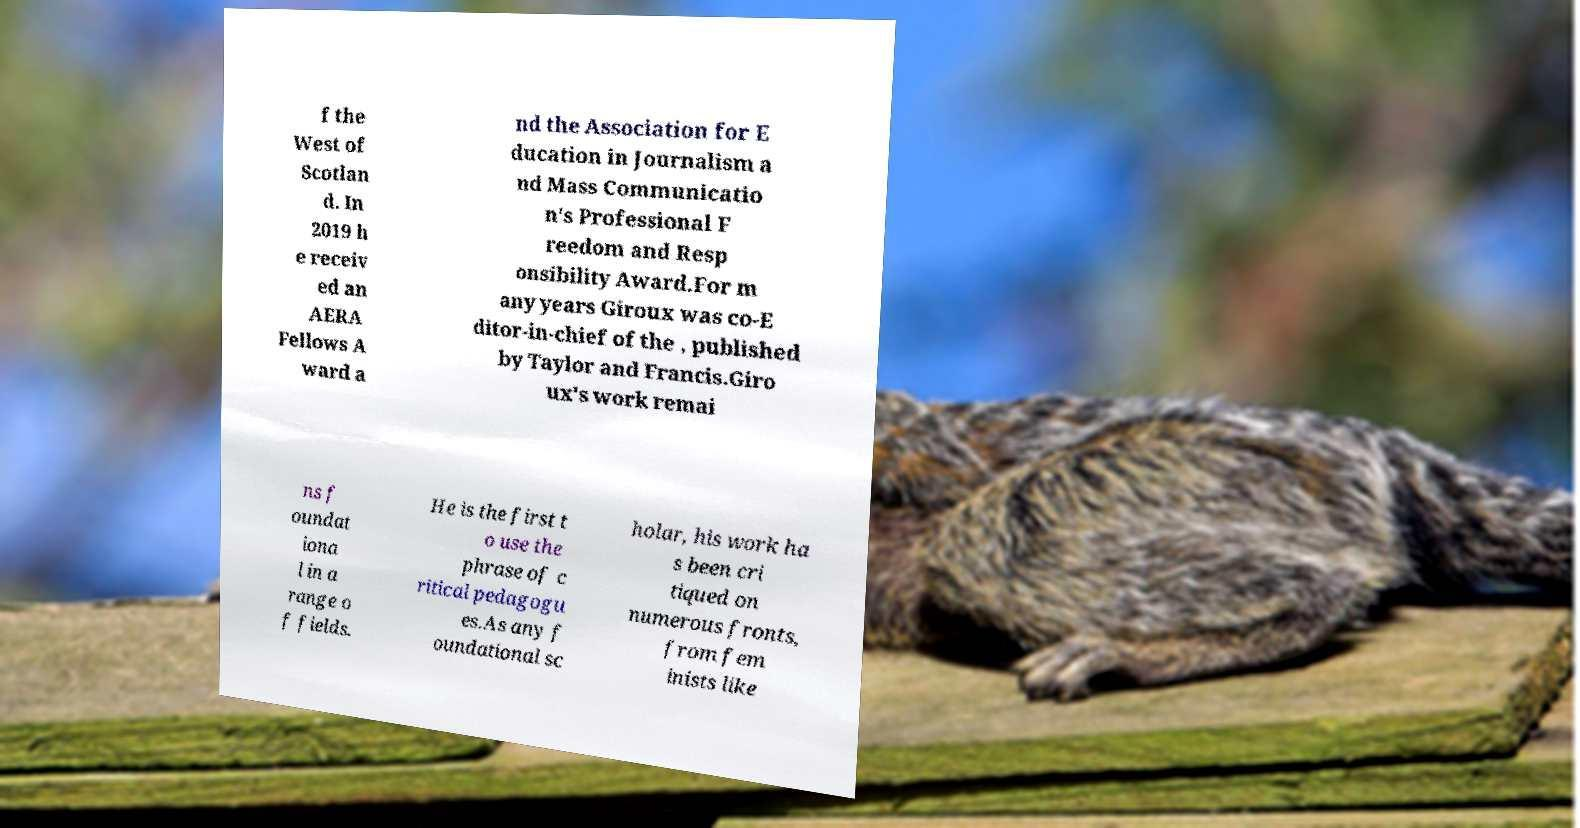Please identify and transcribe the text found in this image. f the West of Scotlan d. In 2019 h e receiv ed an AERA Fellows A ward a nd the Association for E ducation in Journalism a nd Mass Communicatio n's Professional F reedom and Resp onsibility Award.For m any years Giroux was co-E ditor-in-chief of the , published by Taylor and Francis.Giro ux's work remai ns f oundat iona l in a range o f fields. He is the first t o use the phrase of c ritical pedagogu es.As any f oundational sc holar, his work ha s been cri tiqued on numerous fronts, from fem inists like 